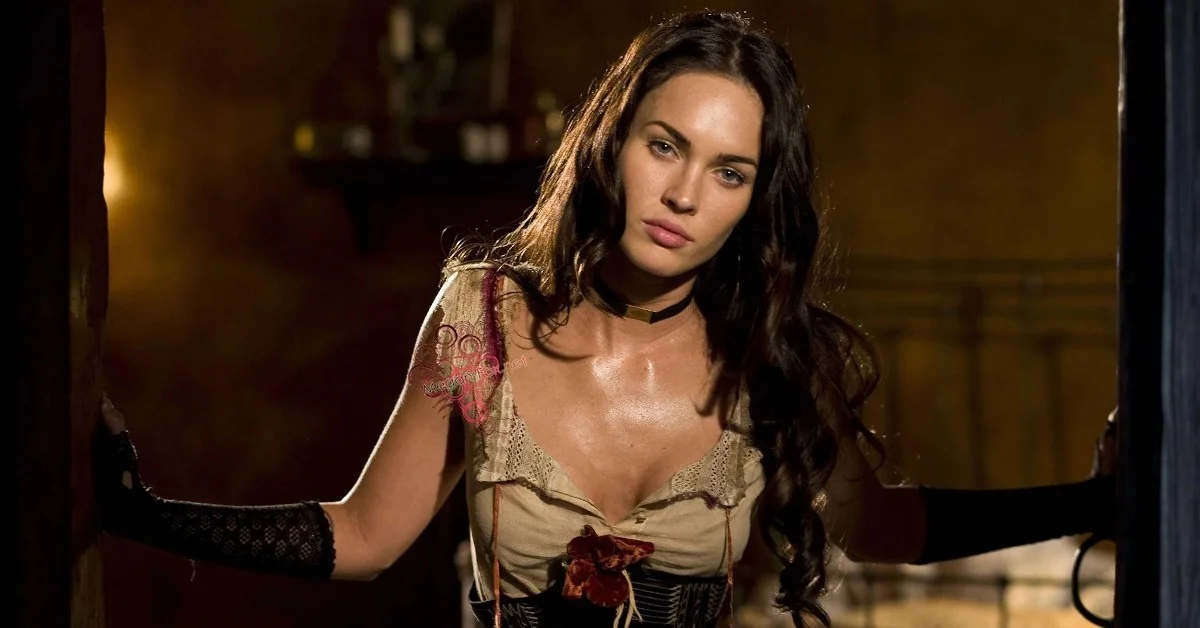What historical era might the fashion in the image suggest, and why? The fashion depicted in the image suggests a late 19th-century or early 20th-century Victorian influence. This is indicated by the tight-fitting corset, which was popular during that time to achieve a cinched waist, and the detailed lace and floral adornments that add to the romantic aesthetics of the era. The gloves also complement this interpretation, typically worn as a sign of sophistication and modesty during that period. 